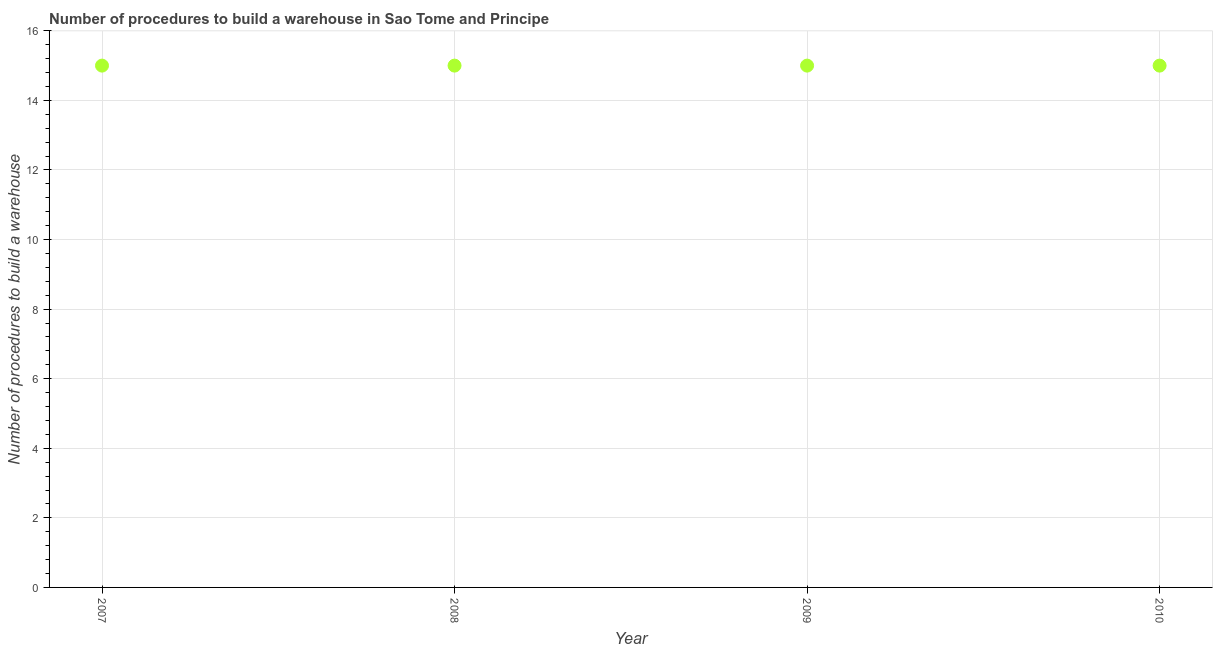What is the number of procedures to build a warehouse in 2009?
Your response must be concise. 15. Across all years, what is the maximum number of procedures to build a warehouse?
Provide a succinct answer. 15. Across all years, what is the minimum number of procedures to build a warehouse?
Your answer should be compact. 15. In which year was the number of procedures to build a warehouse maximum?
Make the answer very short. 2007. What is the sum of the number of procedures to build a warehouse?
Your response must be concise. 60. What is the difference between the number of procedures to build a warehouse in 2007 and 2009?
Your answer should be very brief. 0. What is the median number of procedures to build a warehouse?
Offer a terse response. 15. In how many years, is the number of procedures to build a warehouse greater than 1.6 ?
Offer a terse response. 4. Is the number of procedures to build a warehouse in 2007 less than that in 2008?
Offer a terse response. No. Is the difference between the number of procedures to build a warehouse in 2007 and 2010 greater than the difference between any two years?
Offer a very short reply. Yes. What is the difference between the highest and the lowest number of procedures to build a warehouse?
Make the answer very short. 0. Does the number of procedures to build a warehouse monotonically increase over the years?
Provide a short and direct response. No. How many dotlines are there?
Offer a very short reply. 1. Does the graph contain any zero values?
Your answer should be very brief. No. Does the graph contain grids?
Provide a short and direct response. Yes. What is the title of the graph?
Provide a succinct answer. Number of procedures to build a warehouse in Sao Tome and Principe. What is the label or title of the X-axis?
Ensure brevity in your answer.  Year. What is the label or title of the Y-axis?
Your answer should be compact. Number of procedures to build a warehouse. What is the Number of procedures to build a warehouse in 2007?
Offer a terse response. 15. What is the Number of procedures to build a warehouse in 2009?
Keep it short and to the point. 15. What is the Number of procedures to build a warehouse in 2010?
Your response must be concise. 15. What is the difference between the Number of procedures to build a warehouse in 2007 and 2009?
Make the answer very short. 0. What is the difference between the Number of procedures to build a warehouse in 2007 and 2010?
Give a very brief answer. 0. What is the difference between the Number of procedures to build a warehouse in 2008 and 2009?
Keep it short and to the point. 0. What is the ratio of the Number of procedures to build a warehouse in 2007 to that in 2008?
Offer a terse response. 1. What is the ratio of the Number of procedures to build a warehouse in 2008 to that in 2009?
Provide a succinct answer. 1. 